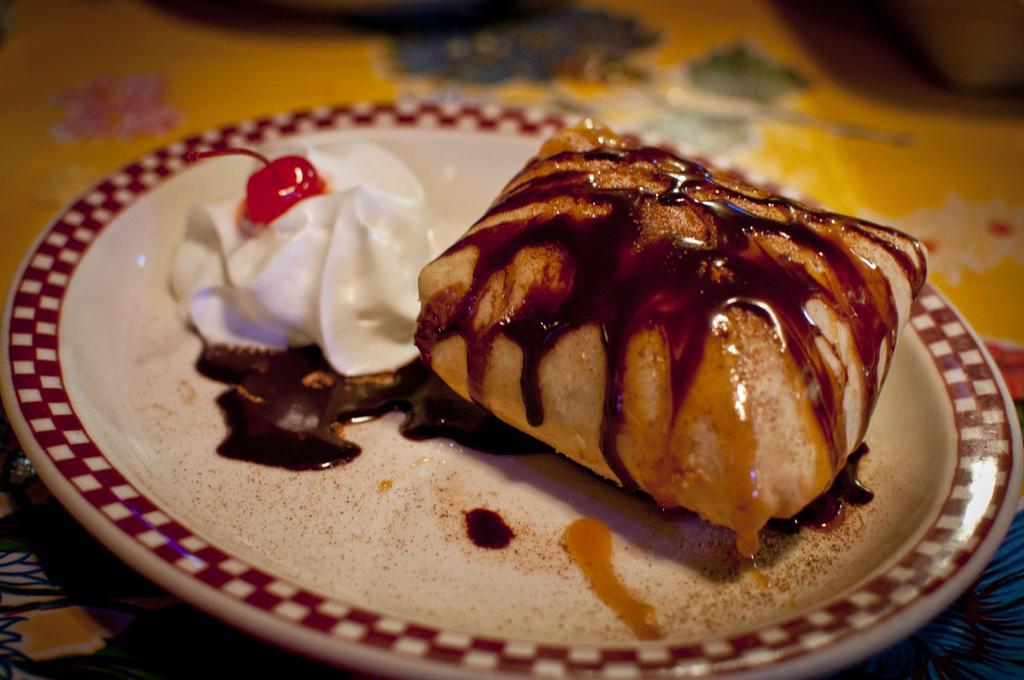How would you summarize this image in a sentence or two? On this plate there is a food. Background it is blur. 